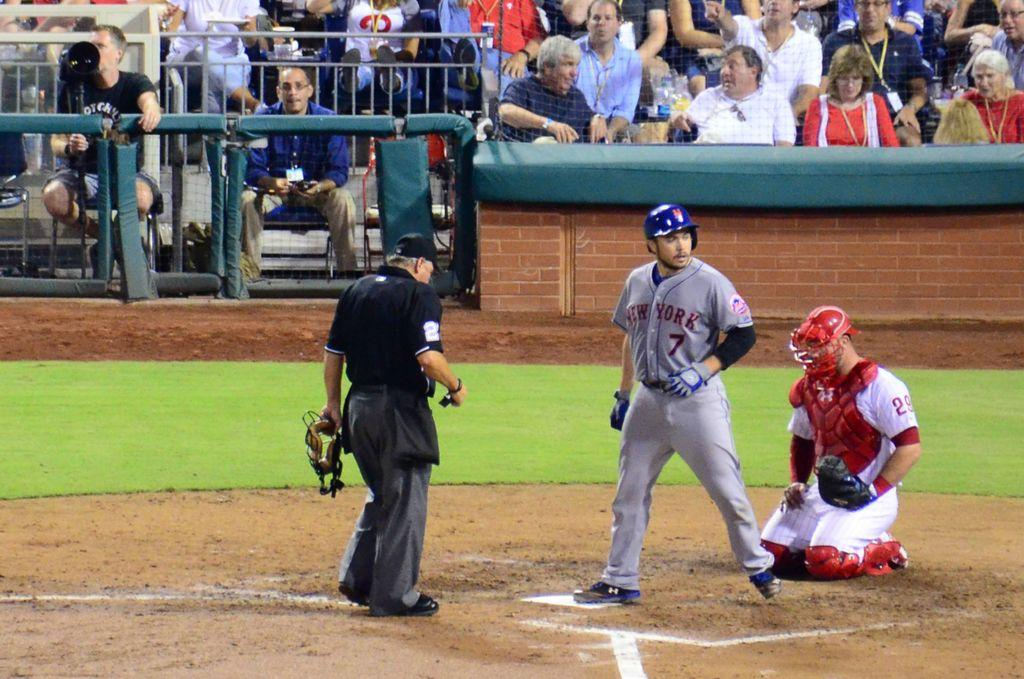Provide a one-sentence caption for the provided image. New York Mets baseball player #7 looking into left field from home plate. 